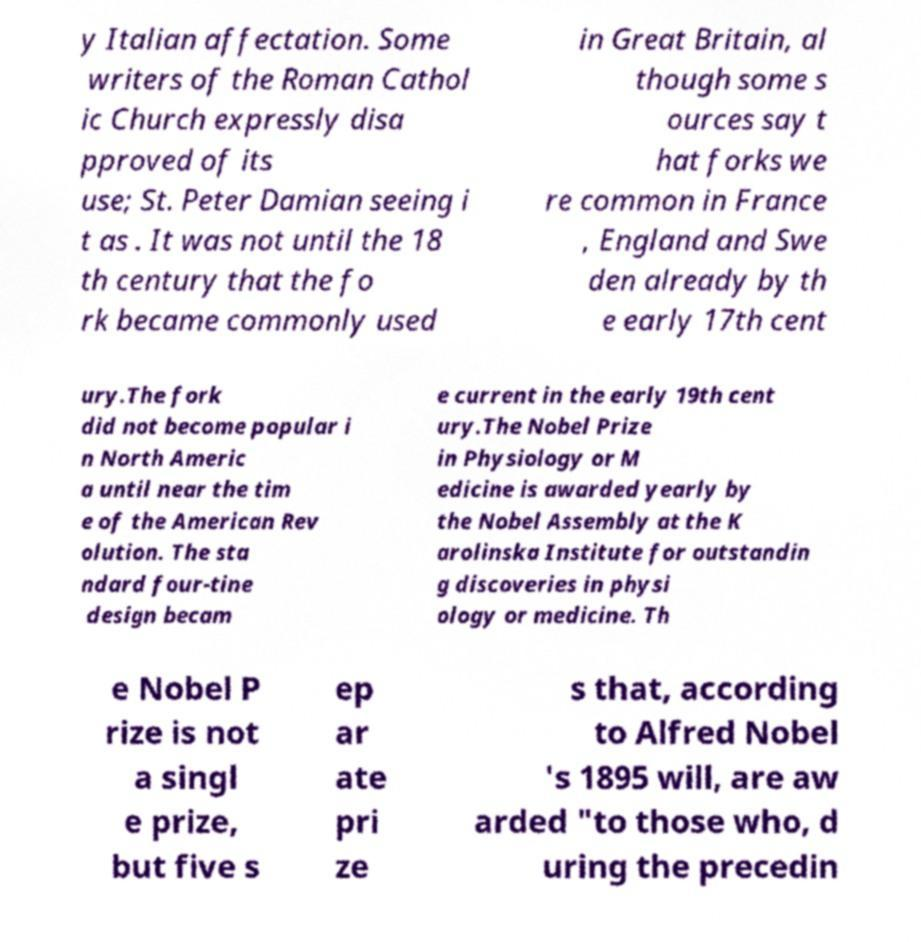What messages or text are displayed in this image? I need them in a readable, typed format. y Italian affectation. Some writers of the Roman Cathol ic Church expressly disa pproved of its use; St. Peter Damian seeing i t as . It was not until the 18 th century that the fo rk became commonly used in Great Britain, al though some s ources say t hat forks we re common in France , England and Swe den already by th e early 17th cent ury.The fork did not become popular i n North Americ a until near the tim e of the American Rev olution. The sta ndard four-tine design becam e current in the early 19th cent ury.The Nobel Prize in Physiology or M edicine is awarded yearly by the Nobel Assembly at the K arolinska Institute for outstandin g discoveries in physi ology or medicine. Th e Nobel P rize is not a singl e prize, but five s ep ar ate pri ze s that, according to Alfred Nobel 's 1895 will, are aw arded "to those who, d uring the precedin 